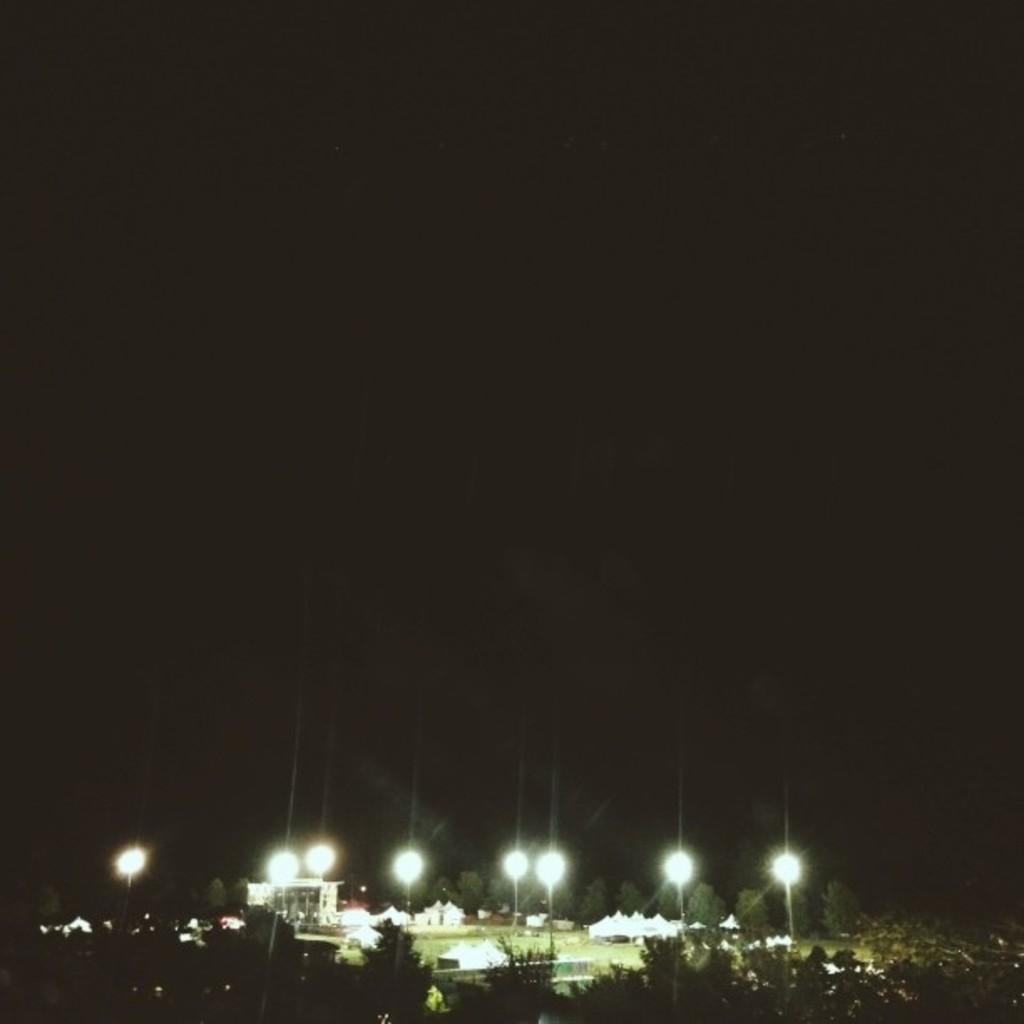In one or two sentences, can you explain what this image depicts? In this image I can see at the bottom there are trees, lights, buildings. At the top it is the sky in the nighttime. 